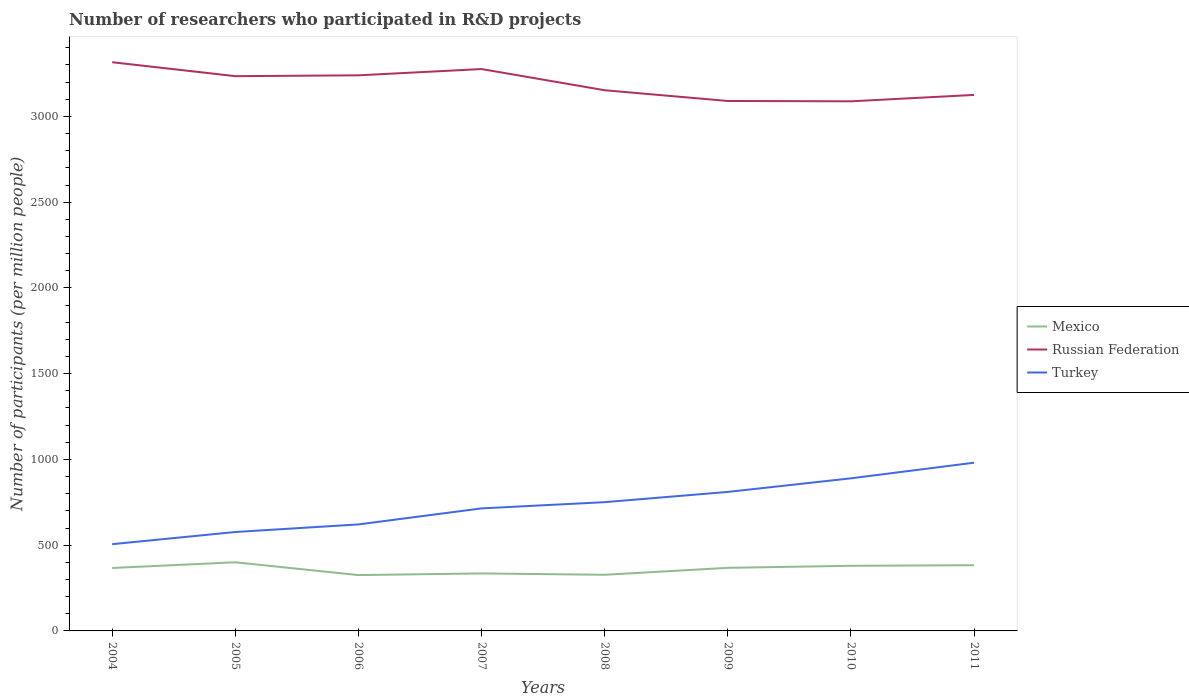Does the line corresponding to Turkey intersect with the line corresponding to Mexico?
Your answer should be very brief. No. Across all years, what is the maximum number of researchers who participated in R&D projects in Mexico?
Provide a short and direct response. 325.58. In which year was the number of researchers who participated in R&D projects in Russian Federation maximum?
Keep it short and to the point. 2010. What is the total number of researchers who participated in R&D projects in Mexico in the graph?
Ensure brevity in your answer.  -0.93. What is the difference between the highest and the second highest number of researchers who participated in R&D projects in Mexico?
Offer a terse response. 74.63. Is the number of researchers who participated in R&D projects in Mexico strictly greater than the number of researchers who participated in R&D projects in Russian Federation over the years?
Keep it short and to the point. Yes. How many lines are there?
Your response must be concise. 3. Are the values on the major ticks of Y-axis written in scientific E-notation?
Ensure brevity in your answer.  No. Does the graph contain any zero values?
Your response must be concise. No. Where does the legend appear in the graph?
Give a very brief answer. Center right. How many legend labels are there?
Provide a succinct answer. 3. What is the title of the graph?
Make the answer very short. Number of researchers who participated in R&D projects. What is the label or title of the Y-axis?
Provide a short and direct response. Number of participants (per million people). What is the Number of participants (per million people) in Mexico in 2004?
Provide a short and direct response. 366.94. What is the Number of participants (per million people) of Russian Federation in 2004?
Keep it short and to the point. 3315.98. What is the Number of participants (per million people) of Turkey in 2004?
Keep it short and to the point. 505.82. What is the Number of participants (per million people) in Mexico in 2005?
Offer a terse response. 400.21. What is the Number of participants (per million people) of Russian Federation in 2005?
Ensure brevity in your answer.  3234.71. What is the Number of participants (per million people) of Turkey in 2005?
Your response must be concise. 576.76. What is the Number of participants (per million people) in Mexico in 2006?
Your response must be concise. 325.58. What is the Number of participants (per million people) in Russian Federation in 2006?
Your answer should be compact. 3239.59. What is the Number of participants (per million people) in Turkey in 2006?
Your answer should be very brief. 620.97. What is the Number of participants (per million people) in Mexico in 2007?
Your response must be concise. 335.25. What is the Number of participants (per million people) of Russian Federation in 2007?
Your answer should be very brief. 3276.12. What is the Number of participants (per million people) in Turkey in 2007?
Provide a succinct answer. 714.49. What is the Number of participants (per million people) of Mexico in 2008?
Your answer should be compact. 327.37. What is the Number of participants (per million people) of Russian Federation in 2008?
Your response must be concise. 3152.62. What is the Number of participants (per million people) in Turkey in 2008?
Offer a terse response. 750.75. What is the Number of participants (per million people) of Mexico in 2009?
Your answer should be very brief. 367.87. What is the Number of participants (per million people) of Russian Federation in 2009?
Your answer should be compact. 3090.01. What is the Number of participants (per million people) in Turkey in 2009?
Offer a very short reply. 810.52. What is the Number of participants (per million people) of Mexico in 2010?
Offer a very short reply. 379.75. What is the Number of participants (per million people) of Russian Federation in 2010?
Your response must be concise. 3087.99. What is the Number of participants (per million people) in Turkey in 2010?
Provide a short and direct response. 889.79. What is the Number of participants (per million people) in Mexico in 2011?
Your answer should be very brief. 383.21. What is the Number of participants (per million people) of Russian Federation in 2011?
Your response must be concise. 3125.3. What is the Number of participants (per million people) in Turkey in 2011?
Keep it short and to the point. 980.84. Across all years, what is the maximum Number of participants (per million people) in Mexico?
Provide a short and direct response. 400.21. Across all years, what is the maximum Number of participants (per million people) in Russian Federation?
Offer a very short reply. 3315.98. Across all years, what is the maximum Number of participants (per million people) in Turkey?
Provide a succinct answer. 980.84. Across all years, what is the minimum Number of participants (per million people) in Mexico?
Keep it short and to the point. 325.58. Across all years, what is the minimum Number of participants (per million people) in Russian Federation?
Your answer should be compact. 3087.99. Across all years, what is the minimum Number of participants (per million people) of Turkey?
Provide a succinct answer. 505.82. What is the total Number of participants (per million people) in Mexico in the graph?
Keep it short and to the point. 2886.17. What is the total Number of participants (per million people) of Russian Federation in the graph?
Your answer should be compact. 2.55e+04. What is the total Number of participants (per million people) of Turkey in the graph?
Keep it short and to the point. 5849.93. What is the difference between the Number of participants (per million people) of Mexico in 2004 and that in 2005?
Ensure brevity in your answer.  -33.27. What is the difference between the Number of participants (per million people) of Russian Federation in 2004 and that in 2005?
Give a very brief answer. 81.27. What is the difference between the Number of participants (per million people) in Turkey in 2004 and that in 2005?
Keep it short and to the point. -70.94. What is the difference between the Number of participants (per million people) in Mexico in 2004 and that in 2006?
Provide a short and direct response. 41.36. What is the difference between the Number of participants (per million people) in Russian Federation in 2004 and that in 2006?
Provide a succinct answer. 76.4. What is the difference between the Number of participants (per million people) of Turkey in 2004 and that in 2006?
Provide a succinct answer. -115.15. What is the difference between the Number of participants (per million people) of Mexico in 2004 and that in 2007?
Give a very brief answer. 31.69. What is the difference between the Number of participants (per million people) of Russian Federation in 2004 and that in 2007?
Give a very brief answer. 39.86. What is the difference between the Number of participants (per million people) in Turkey in 2004 and that in 2007?
Your answer should be very brief. -208.67. What is the difference between the Number of participants (per million people) of Mexico in 2004 and that in 2008?
Ensure brevity in your answer.  39.57. What is the difference between the Number of participants (per million people) of Russian Federation in 2004 and that in 2008?
Provide a short and direct response. 163.36. What is the difference between the Number of participants (per million people) of Turkey in 2004 and that in 2008?
Provide a succinct answer. -244.93. What is the difference between the Number of participants (per million people) in Mexico in 2004 and that in 2009?
Provide a short and direct response. -0.93. What is the difference between the Number of participants (per million people) in Russian Federation in 2004 and that in 2009?
Offer a very short reply. 225.97. What is the difference between the Number of participants (per million people) of Turkey in 2004 and that in 2009?
Make the answer very short. -304.7. What is the difference between the Number of participants (per million people) of Mexico in 2004 and that in 2010?
Offer a terse response. -12.81. What is the difference between the Number of participants (per million people) in Russian Federation in 2004 and that in 2010?
Offer a terse response. 227.99. What is the difference between the Number of participants (per million people) in Turkey in 2004 and that in 2010?
Offer a very short reply. -383.97. What is the difference between the Number of participants (per million people) in Mexico in 2004 and that in 2011?
Keep it short and to the point. -16.27. What is the difference between the Number of participants (per million people) of Russian Federation in 2004 and that in 2011?
Your response must be concise. 190.68. What is the difference between the Number of participants (per million people) in Turkey in 2004 and that in 2011?
Offer a terse response. -475.02. What is the difference between the Number of participants (per million people) in Mexico in 2005 and that in 2006?
Your answer should be very brief. 74.63. What is the difference between the Number of participants (per million people) in Russian Federation in 2005 and that in 2006?
Ensure brevity in your answer.  -4.88. What is the difference between the Number of participants (per million people) of Turkey in 2005 and that in 2006?
Your answer should be very brief. -44.21. What is the difference between the Number of participants (per million people) in Mexico in 2005 and that in 2007?
Give a very brief answer. 64.96. What is the difference between the Number of participants (per million people) in Russian Federation in 2005 and that in 2007?
Provide a short and direct response. -41.41. What is the difference between the Number of participants (per million people) in Turkey in 2005 and that in 2007?
Your response must be concise. -137.73. What is the difference between the Number of participants (per million people) of Mexico in 2005 and that in 2008?
Your answer should be compact. 72.84. What is the difference between the Number of participants (per million people) in Russian Federation in 2005 and that in 2008?
Make the answer very short. 82.09. What is the difference between the Number of participants (per million people) in Turkey in 2005 and that in 2008?
Keep it short and to the point. -173.99. What is the difference between the Number of participants (per million people) in Mexico in 2005 and that in 2009?
Your answer should be compact. 32.34. What is the difference between the Number of participants (per million people) of Russian Federation in 2005 and that in 2009?
Offer a very short reply. 144.7. What is the difference between the Number of participants (per million people) of Turkey in 2005 and that in 2009?
Provide a succinct answer. -233.76. What is the difference between the Number of participants (per million people) of Mexico in 2005 and that in 2010?
Offer a very short reply. 20.46. What is the difference between the Number of participants (per million people) in Russian Federation in 2005 and that in 2010?
Ensure brevity in your answer.  146.72. What is the difference between the Number of participants (per million people) in Turkey in 2005 and that in 2010?
Offer a terse response. -313.03. What is the difference between the Number of participants (per million people) in Mexico in 2005 and that in 2011?
Offer a very short reply. 17. What is the difference between the Number of participants (per million people) of Russian Federation in 2005 and that in 2011?
Your answer should be compact. 109.41. What is the difference between the Number of participants (per million people) in Turkey in 2005 and that in 2011?
Give a very brief answer. -404.09. What is the difference between the Number of participants (per million people) of Mexico in 2006 and that in 2007?
Give a very brief answer. -9.67. What is the difference between the Number of participants (per million people) in Russian Federation in 2006 and that in 2007?
Offer a terse response. -36.54. What is the difference between the Number of participants (per million people) of Turkey in 2006 and that in 2007?
Offer a very short reply. -93.52. What is the difference between the Number of participants (per million people) in Mexico in 2006 and that in 2008?
Ensure brevity in your answer.  -1.79. What is the difference between the Number of participants (per million people) in Russian Federation in 2006 and that in 2008?
Offer a very short reply. 86.96. What is the difference between the Number of participants (per million people) of Turkey in 2006 and that in 2008?
Ensure brevity in your answer.  -129.78. What is the difference between the Number of participants (per million people) of Mexico in 2006 and that in 2009?
Ensure brevity in your answer.  -42.29. What is the difference between the Number of participants (per million people) of Russian Federation in 2006 and that in 2009?
Provide a short and direct response. 149.57. What is the difference between the Number of participants (per million people) of Turkey in 2006 and that in 2009?
Provide a short and direct response. -189.55. What is the difference between the Number of participants (per million people) of Mexico in 2006 and that in 2010?
Give a very brief answer. -54.17. What is the difference between the Number of participants (per million people) in Russian Federation in 2006 and that in 2010?
Provide a succinct answer. 151.59. What is the difference between the Number of participants (per million people) in Turkey in 2006 and that in 2010?
Your response must be concise. -268.82. What is the difference between the Number of participants (per million people) of Mexico in 2006 and that in 2011?
Offer a terse response. -57.63. What is the difference between the Number of participants (per million people) in Russian Federation in 2006 and that in 2011?
Make the answer very short. 114.28. What is the difference between the Number of participants (per million people) of Turkey in 2006 and that in 2011?
Give a very brief answer. -359.87. What is the difference between the Number of participants (per million people) in Mexico in 2007 and that in 2008?
Your answer should be compact. 7.88. What is the difference between the Number of participants (per million people) of Russian Federation in 2007 and that in 2008?
Provide a succinct answer. 123.5. What is the difference between the Number of participants (per million people) of Turkey in 2007 and that in 2008?
Your answer should be very brief. -36.26. What is the difference between the Number of participants (per million people) of Mexico in 2007 and that in 2009?
Give a very brief answer. -32.62. What is the difference between the Number of participants (per million people) of Russian Federation in 2007 and that in 2009?
Offer a very short reply. 186.11. What is the difference between the Number of participants (per million people) in Turkey in 2007 and that in 2009?
Offer a very short reply. -96.03. What is the difference between the Number of participants (per million people) of Mexico in 2007 and that in 2010?
Offer a very short reply. -44.5. What is the difference between the Number of participants (per million people) of Russian Federation in 2007 and that in 2010?
Give a very brief answer. 188.13. What is the difference between the Number of participants (per million people) of Turkey in 2007 and that in 2010?
Provide a short and direct response. -175.3. What is the difference between the Number of participants (per million people) of Mexico in 2007 and that in 2011?
Offer a terse response. -47.96. What is the difference between the Number of participants (per million people) of Russian Federation in 2007 and that in 2011?
Offer a very short reply. 150.82. What is the difference between the Number of participants (per million people) of Turkey in 2007 and that in 2011?
Provide a short and direct response. -266.36. What is the difference between the Number of participants (per million people) in Mexico in 2008 and that in 2009?
Keep it short and to the point. -40.49. What is the difference between the Number of participants (per million people) in Russian Federation in 2008 and that in 2009?
Give a very brief answer. 62.61. What is the difference between the Number of participants (per million people) in Turkey in 2008 and that in 2009?
Make the answer very short. -59.77. What is the difference between the Number of participants (per million people) of Mexico in 2008 and that in 2010?
Provide a short and direct response. -52.38. What is the difference between the Number of participants (per million people) of Russian Federation in 2008 and that in 2010?
Ensure brevity in your answer.  64.63. What is the difference between the Number of participants (per million people) in Turkey in 2008 and that in 2010?
Provide a short and direct response. -139.04. What is the difference between the Number of participants (per million people) in Mexico in 2008 and that in 2011?
Your response must be concise. -55.84. What is the difference between the Number of participants (per million people) of Russian Federation in 2008 and that in 2011?
Give a very brief answer. 27.32. What is the difference between the Number of participants (per million people) in Turkey in 2008 and that in 2011?
Offer a very short reply. -230.09. What is the difference between the Number of participants (per million people) of Mexico in 2009 and that in 2010?
Keep it short and to the point. -11.88. What is the difference between the Number of participants (per million people) of Russian Federation in 2009 and that in 2010?
Keep it short and to the point. 2.02. What is the difference between the Number of participants (per million people) of Turkey in 2009 and that in 2010?
Provide a short and direct response. -79.27. What is the difference between the Number of participants (per million people) in Mexico in 2009 and that in 2011?
Offer a terse response. -15.34. What is the difference between the Number of participants (per million people) in Russian Federation in 2009 and that in 2011?
Provide a short and direct response. -35.29. What is the difference between the Number of participants (per million people) of Turkey in 2009 and that in 2011?
Make the answer very short. -170.32. What is the difference between the Number of participants (per million people) of Mexico in 2010 and that in 2011?
Keep it short and to the point. -3.46. What is the difference between the Number of participants (per million people) in Russian Federation in 2010 and that in 2011?
Your answer should be compact. -37.31. What is the difference between the Number of participants (per million people) of Turkey in 2010 and that in 2011?
Ensure brevity in your answer.  -91.05. What is the difference between the Number of participants (per million people) of Mexico in 2004 and the Number of participants (per million people) of Russian Federation in 2005?
Your answer should be very brief. -2867.77. What is the difference between the Number of participants (per million people) in Mexico in 2004 and the Number of participants (per million people) in Turkey in 2005?
Your answer should be compact. -209.82. What is the difference between the Number of participants (per million people) of Russian Federation in 2004 and the Number of participants (per million people) of Turkey in 2005?
Ensure brevity in your answer.  2739.23. What is the difference between the Number of participants (per million people) in Mexico in 2004 and the Number of participants (per million people) in Russian Federation in 2006?
Your answer should be compact. -2872.65. What is the difference between the Number of participants (per million people) in Mexico in 2004 and the Number of participants (per million people) in Turkey in 2006?
Ensure brevity in your answer.  -254.03. What is the difference between the Number of participants (per million people) in Russian Federation in 2004 and the Number of participants (per million people) in Turkey in 2006?
Make the answer very short. 2695.01. What is the difference between the Number of participants (per million people) in Mexico in 2004 and the Number of participants (per million people) in Russian Federation in 2007?
Offer a very short reply. -2909.18. What is the difference between the Number of participants (per million people) of Mexico in 2004 and the Number of participants (per million people) of Turkey in 2007?
Keep it short and to the point. -347.55. What is the difference between the Number of participants (per million people) in Russian Federation in 2004 and the Number of participants (per million people) in Turkey in 2007?
Offer a very short reply. 2601.5. What is the difference between the Number of participants (per million people) of Mexico in 2004 and the Number of participants (per million people) of Russian Federation in 2008?
Offer a terse response. -2785.68. What is the difference between the Number of participants (per million people) in Mexico in 2004 and the Number of participants (per million people) in Turkey in 2008?
Provide a short and direct response. -383.81. What is the difference between the Number of participants (per million people) in Russian Federation in 2004 and the Number of participants (per million people) in Turkey in 2008?
Keep it short and to the point. 2565.23. What is the difference between the Number of participants (per million people) of Mexico in 2004 and the Number of participants (per million people) of Russian Federation in 2009?
Give a very brief answer. -2723.07. What is the difference between the Number of participants (per million people) in Mexico in 2004 and the Number of participants (per million people) in Turkey in 2009?
Ensure brevity in your answer.  -443.58. What is the difference between the Number of participants (per million people) of Russian Federation in 2004 and the Number of participants (per million people) of Turkey in 2009?
Ensure brevity in your answer.  2505.46. What is the difference between the Number of participants (per million people) in Mexico in 2004 and the Number of participants (per million people) in Russian Federation in 2010?
Your response must be concise. -2721.05. What is the difference between the Number of participants (per million people) of Mexico in 2004 and the Number of participants (per million people) of Turkey in 2010?
Ensure brevity in your answer.  -522.85. What is the difference between the Number of participants (per million people) in Russian Federation in 2004 and the Number of participants (per million people) in Turkey in 2010?
Your response must be concise. 2426.19. What is the difference between the Number of participants (per million people) of Mexico in 2004 and the Number of participants (per million people) of Russian Federation in 2011?
Offer a terse response. -2758.36. What is the difference between the Number of participants (per million people) of Mexico in 2004 and the Number of participants (per million people) of Turkey in 2011?
Give a very brief answer. -613.9. What is the difference between the Number of participants (per million people) of Russian Federation in 2004 and the Number of participants (per million people) of Turkey in 2011?
Your response must be concise. 2335.14. What is the difference between the Number of participants (per million people) of Mexico in 2005 and the Number of participants (per million people) of Russian Federation in 2006?
Offer a terse response. -2839.38. What is the difference between the Number of participants (per million people) of Mexico in 2005 and the Number of participants (per million people) of Turkey in 2006?
Provide a short and direct response. -220.76. What is the difference between the Number of participants (per million people) of Russian Federation in 2005 and the Number of participants (per million people) of Turkey in 2006?
Provide a succinct answer. 2613.74. What is the difference between the Number of participants (per million people) of Mexico in 2005 and the Number of participants (per million people) of Russian Federation in 2007?
Offer a terse response. -2875.91. What is the difference between the Number of participants (per million people) of Mexico in 2005 and the Number of participants (per million people) of Turkey in 2007?
Provide a short and direct response. -314.28. What is the difference between the Number of participants (per million people) of Russian Federation in 2005 and the Number of participants (per million people) of Turkey in 2007?
Make the answer very short. 2520.22. What is the difference between the Number of participants (per million people) in Mexico in 2005 and the Number of participants (per million people) in Russian Federation in 2008?
Your answer should be very brief. -2752.41. What is the difference between the Number of participants (per million people) of Mexico in 2005 and the Number of participants (per million people) of Turkey in 2008?
Your answer should be very brief. -350.54. What is the difference between the Number of participants (per million people) of Russian Federation in 2005 and the Number of participants (per million people) of Turkey in 2008?
Give a very brief answer. 2483.96. What is the difference between the Number of participants (per million people) in Mexico in 2005 and the Number of participants (per million people) in Russian Federation in 2009?
Provide a succinct answer. -2689.8. What is the difference between the Number of participants (per million people) of Mexico in 2005 and the Number of participants (per million people) of Turkey in 2009?
Offer a very short reply. -410.31. What is the difference between the Number of participants (per million people) in Russian Federation in 2005 and the Number of participants (per million people) in Turkey in 2009?
Ensure brevity in your answer.  2424.19. What is the difference between the Number of participants (per million people) in Mexico in 2005 and the Number of participants (per million people) in Russian Federation in 2010?
Offer a terse response. -2687.78. What is the difference between the Number of participants (per million people) of Mexico in 2005 and the Number of participants (per million people) of Turkey in 2010?
Offer a terse response. -489.58. What is the difference between the Number of participants (per million people) of Russian Federation in 2005 and the Number of participants (per million people) of Turkey in 2010?
Offer a terse response. 2344.92. What is the difference between the Number of participants (per million people) in Mexico in 2005 and the Number of participants (per million people) in Russian Federation in 2011?
Offer a terse response. -2725.09. What is the difference between the Number of participants (per million people) in Mexico in 2005 and the Number of participants (per million people) in Turkey in 2011?
Provide a short and direct response. -580.63. What is the difference between the Number of participants (per million people) in Russian Federation in 2005 and the Number of participants (per million people) in Turkey in 2011?
Keep it short and to the point. 2253.87. What is the difference between the Number of participants (per million people) in Mexico in 2006 and the Number of participants (per million people) in Russian Federation in 2007?
Provide a short and direct response. -2950.54. What is the difference between the Number of participants (per million people) of Mexico in 2006 and the Number of participants (per million people) of Turkey in 2007?
Provide a succinct answer. -388.91. What is the difference between the Number of participants (per million people) in Russian Federation in 2006 and the Number of participants (per million people) in Turkey in 2007?
Your answer should be compact. 2525.1. What is the difference between the Number of participants (per million people) of Mexico in 2006 and the Number of participants (per million people) of Russian Federation in 2008?
Ensure brevity in your answer.  -2827.04. What is the difference between the Number of participants (per million people) of Mexico in 2006 and the Number of participants (per million people) of Turkey in 2008?
Your answer should be compact. -425.17. What is the difference between the Number of participants (per million people) of Russian Federation in 2006 and the Number of participants (per million people) of Turkey in 2008?
Provide a succinct answer. 2488.84. What is the difference between the Number of participants (per million people) in Mexico in 2006 and the Number of participants (per million people) in Russian Federation in 2009?
Your response must be concise. -2764.43. What is the difference between the Number of participants (per million people) of Mexico in 2006 and the Number of participants (per million people) of Turkey in 2009?
Provide a short and direct response. -484.94. What is the difference between the Number of participants (per million people) of Russian Federation in 2006 and the Number of participants (per million people) of Turkey in 2009?
Give a very brief answer. 2429.07. What is the difference between the Number of participants (per million people) in Mexico in 2006 and the Number of participants (per million people) in Russian Federation in 2010?
Your answer should be very brief. -2762.41. What is the difference between the Number of participants (per million people) in Mexico in 2006 and the Number of participants (per million people) in Turkey in 2010?
Ensure brevity in your answer.  -564.21. What is the difference between the Number of participants (per million people) in Russian Federation in 2006 and the Number of participants (per million people) in Turkey in 2010?
Make the answer very short. 2349.8. What is the difference between the Number of participants (per million people) in Mexico in 2006 and the Number of participants (per million people) in Russian Federation in 2011?
Ensure brevity in your answer.  -2799.72. What is the difference between the Number of participants (per million people) in Mexico in 2006 and the Number of participants (per million people) in Turkey in 2011?
Offer a very short reply. -655.26. What is the difference between the Number of participants (per million people) in Russian Federation in 2006 and the Number of participants (per million people) in Turkey in 2011?
Offer a very short reply. 2258.74. What is the difference between the Number of participants (per million people) of Mexico in 2007 and the Number of participants (per million people) of Russian Federation in 2008?
Provide a succinct answer. -2817.37. What is the difference between the Number of participants (per million people) in Mexico in 2007 and the Number of participants (per million people) in Turkey in 2008?
Ensure brevity in your answer.  -415.5. What is the difference between the Number of participants (per million people) in Russian Federation in 2007 and the Number of participants (per million people) in Turkey in 2008?
Offer a very short reply. 2525.37. What is the difference between the Number of participants (per million people) in Mexico in 2007 and the Number of participants (per million people) in Russian Federation in 2009?
Make the answer very short. -2754.76. What is the difference between the Number of participants (per million people) in Mexico in 2007 and the Number of participants (per million people) in Turkey in 2009?
Your response must be concise. -475.27. What is the difference between the Number of participants (per million people) in Russian Federation in 2007 and the Number of participants (per million people) in Turkey in 2009?
Keep it short and to the point. 2465.6. What is the difference between the Number of participants (per million people) in Mexico in 2007 and the Number of participants (per million people) in Russian Federation in 2010?
Your answer should be compact. -2752.74. What is the difference between the Number of participants (per million people) in Mexico in 2007 and the Number of participants (per million people) in Turkey in 2010?
Give a very brief answer. -554.54. What is the difference between the Number of participants (per million people) of Russian Federation in 2007 and the Number of participants (per million people) of Turkey in 2010?
Provide a short and direct response. 2386.33. What is the difference between the Number of participants (per million people) of Mexico in 2007 and the Number of participants (per million people) of Russian Federation in 2011?
Offer a terse response. -2790.05. What is the difference between the Number of participants (per million people) of Mexico in 2007 and the Number of participants (per million people) of Turkey in 2011?
Make the answer very short. -645.59. What is the difference between the Number of participants (per million people) in Russian Federation in 2007 and the Number of participants (per million people) in Turkey in 2011?
Provide a short and direct response. 2295.28. What is the difference between the Number of participants (per million people) of Mexico in 2008 and the Number of participants (per million people) of Russian Federation in 2009?
Your answer should be very brief. -2762.64. What is the difference between the Number of participants (per million people) in Mexico in 2008 and the Number of participants (per million people) in Turkey in 2009?
Keep it short and to the point. -483.15. What is the difference between the Number of participants (per million people) in Russian Federation in 2008 and the Number of participants (per million people) in Turkey in 2009?
Keep it short and to the point. 2342.1. What is the difference between the Number of participants (per million people) in Mexico in 2008 and the Number of participants (per million people) in Russian Federation in 2010?
Offer a very short reply. -2760.62. What is the difference between the Number of participants (per million people) of Mexico in 2008 and the Number of participants (per million people) of Turkey in 2010?
Ensure brevity in your answer.  -562.42. What is the difference between the Number of participants (per million people) in Russian Federation in 2008 and the Number of participants (per million people) in Turkey in 2010?
Ensure brevity in your answer.  2262.83. What is the difference between the Number of participants (per million people) of Mexico in 2008 and the Number of participants (per million people) of Russian Federation in 2011?
Ensure brevity in your answer.  -2797.93. What is the difference between the Number of participants (per million people) in Mexico in 2008 and the Number of participants (per million people) in Turkey in 2011?
Make the answer very short. -653.47. What is the difference between the Number of participants (per million people) in Russian Federation in 2008 and the Number of participants (per million people) in Turkey in 2011?
Ensure brevity in your answer.  2171.78. What is the difference between the Number of participants (per million people) of Mexico in 2009 and the Number of participants (per million people) of Russian Federation in 2010?
Provide a short and direct response. -2720.12. What is the difference between the Number of participants (per million people) in Mexico in 2009 and the Number of participants (per million people) in Turkey in 2010?
Offer a terse response. -521.92. What is the difference between the Number of participants (per million people) of Russian Federation in 2009 and the Number of participants (per million people) of Turkey in 2010?
Provide a succinct answer. 2200.22. What is the difference between the Number of participants (per million people) in Mexico in 2009 and the Number of participants (per million people) in Russian Federation in 2011?
Offer a terse response. -2757.43. What is the difference between the Number of participants (per million people) of Mexico in 2009 and the Number of participants (per million people) of Turkey in 2011?
Your answer should be very brief. -612.98. What is the difference between the Number of participants (per million people) in Russian Federation in 2009 and the Number of participants (per million people) in Turkey in 2011?
Your response must be concise. 2109.17. What is the difference between the Number of participants (per million people) in Mexico in 2010 and the Number of participants (per million people) in Russian Federation in 2011?
Your response must be concise. -2745.55. What is the difference between the Number of participants (per million people) of Mexico in 2010 and the Number of participants (per million people) of Turkey in 2011?
Make the answer very short. -601.09. What is the difference between the Number of participants (per million people) in Russian Federation in 2010 and the Number of participants (per million people) in Turkey in 2011?
Offer a very short reply. 2107.15. What is the average Number of participants (per million people) of Mexico per year?
Your answer should be very brief. 360.77. What is the average Number of participants (per million people) of Russian Federation per year?
Keep it short and to the point. 3190.29. What is the average Number of participants (per million people) in Turkey per year?
Offer a terse response. 731.24. In the year 2004, what is the difference between the Number of participants (per million people) of Mexico and Number of participants (per million people) of Russian Federation?
Your answer should be compact. -2949.04. In the year 2004, what is the difference between the Number of participants (per million people) of Mexico and Number of participants (per million people) of Turkey?
Your answer should be compact. -138.88. In the year 2004, what is the difference between the Number of participants (per million people) in Russian Federation and Number of participants (per million people) in Turkey?
Offer a very short reply. 2810.16. In the year 2005, what is the difference between the Number of participants (per million people) in Mexico and Number of participants (per million people) in Russian Federation?
Offer a very short reply. -2834.5. In the year 2005, what is the difference between the Number of participants (per million people) in Mexico and Number of participants (per million people) in Turkey?
Make the answer very short. -176.55. In the year 2005, what is the difference between the Number of participants (per million people) in Russian Federation and Number of participants (per million people) in Turkey?
Your answer should be compact. 2657.95. In the year 2006, what is the difference between the Number of participants (per million people) in Mexico and Number of participants (per million people) in Russian Federation?
Your answer should be very brief. -2914.01. In the year 2006, what is the difference between the Number of participants (per million people) in Mexico and Number of participants (per million people) in Turkey?
Keep it short and to the point. -295.39. In the year 2006, what is the difference between the Number of participants (per million people) of Russian Federation and Number of participants (per million people) of Turkey?
Your answer should be compact. 2618.62. In the year 2007, what is the difference between the Number of participants (per million people) of Mexico and Number of participants (per million people) of Russian Federation?
Provide a succinct answer. -2940.87. In the year 2007, what is the difference between the Number of participants (per million people) of Mexico and Number of participants (per million people) of Turkey?
Offer a terse response. -379.24. In the year 2007, what is the difference between the Number of participants (per million people) of Russian Federation and Number of participants (per million people) of Turkey?
Ensure brevity in your answer.  2561.64. In the year 2008, what is the difference between the Number of participants (per million people) in Mexico and Number of participants (per million people) in Russian Federation?
Ensure brevity in your answer.  -2825.25. In the year 2008, what is the difference between the Number of participants (per million people) in Mexico and Number of participants (per million people) in Turkey?
Offer a very short reply. -423.38. In the year 2008, what is the difference between the Number of participants (per million people) in Russian Federation and Number of participants (per million people) in Turkey?
Ensure brevity in your answer.  2401.87. In the year 2009, what is the difference between the Number of participants (per million people) in Mexico and Number of participants (per million people) in Russian Federation?
Make the answer very short. -2722.14. In the year 2009, what is the difference between the Number of participants (per million people) of Mexico and Number of participants (per million people) of Turkey?
Offer a very short reply. -442.65. In the year 2009, what is the difference between the Number of participants (per million people) in Russian Federation and Number of participants (per million people) in Turkey?
Offer a very short reply. 2279.49. In the year 2010, what is the difference between the Number of participants (per million people) of Mexico and Number of participants (per million people) of Russian Federation?
Provide a short and direct response. -2708.24. In the year 2010, what is the difference between the Number of participants (per million people) in Mexico and Number of participants (per million people) in Turkey?
Make the answer very short. -510.04. In the year 2010, what is the difference between the Number of participants (per million people) in Russian Federation and Number of participants (per million people) in Turkey?
Ensure brevity in your answer.  2198.2. In the year 2011, what is the difference between the Number of participants (per million people) of Mexico and Number of participants (per million people) of Russian Federation?
Your answer should be very brief. -2742.09. In the year 2011, what is the difference between the Number of participants (per million people) of Mexico and Number of participants (per million people) of Turkey?
Your response must be concise. -597.63. In the year 2011, what is the difference between the Number of participants (per million people) of Russian Federation and Number of participants (per million people) of Turkey?
Give a very brief answer. 2144.46. What is the ratio of the Number of participants (per million people) in Mexico in 2004 to that in 2005?
Provide a succinct answer. 0.92. What is the ratio of the Number of participants (per million people) of Russian Federation in 2004 to that in 2005?
Offer a very short reply. 1.03. What is the ratio of the Number of participants (per million people) in Turkey in 2004 to that in 2005?
Provide a short and direct response. 0.88. What is the ratio of the Number of participants (per million people) in Mexico in 2004 to that in 2006?
Offer a very short reply. 1.13. What is the ratio of the Number of participants (per million people) of Russian Federation in 2004 to that in 2006?
Your answer should be very brief. 1.02. What is the ratio of the Number of participants (per million people) in Turkey in 2004 to that in 2006?
Your response must be concise. 0.81. What is the ratio of the Number of participants (per million people) of Mexico in 2004 to that in 2007?
Your answer should be compact. 1.09. What is the ratio of the Number of participants (per million people) of Russian Federation in 2004 to that in 2007?
Offer a terse response. 1.01. What is the ratio of the Number of participants (per million people) of Turkey in 2004 to that in 2007?
Your answer should be very brief. 0.71. What is the ratio of the Number of participants (per million people) of Mexico in 2004 to that in 2008?
Provide a succinct answer. 1.12. What is the ratio of the Number of participants (per million people) in Russian Federation in 2004 to that in 2008?
Offer a very short reply. 1.05. What is the ratio of the Number of participants (per million people) of Turkey in 2004 to that in 2008?
Keep it short and to the point. 0.67. What is the ratio of the Number of participants (per million people) in Mexico in 2004 to that in 2009?
Your response must be concise. 1. What is the ratio of the Number of participants (per million people) of Russian Federation in 2004 to that in 2009?
Make the answer very short. 1.07. What is the ratio of the Number of participants (per million people) in Turkey in 2004 to that in 2009?
Ensure brevity in your answer.  0.62. What is the ratio of the Number of participants (per million people) of Mexico in 2004 to that in 2010?
Offer a very short reply. 0.97. What is the ratio of the Number of participants (per million people) of Russian Federation in 2004 to that in 2010?
Make the answer very short. 1.07. What is the ratio of the Number of participants (per million people) of Turkey in 2004 to that in 2010?
Your answer should be very brief. 0.57. What is the ratio of the Number of participants (per million people) in Mexico in 2004 to that in 2011?
Offer a very short reply. 0.96. What is the ratio of the Number of participants (per million people) in Russian Federation in 2004 to that in 2011?
Your response must be concise. 1.06. What is the ratio of the Number of participants (per million people) of Turkey in 2004 to that in 2011?
Your answer should be very brief. 0.52. What is the ratio of the Number of participants (per million people) in Mexico in 2005 to that in 2006?
Make the answer very short. 1.23. What is the ratio of the Number of participants (per million people) of Russian Federation in 2005 to that in 2006?
Your answer should be very brief. 1. What is the ratio of the Number of participants (per million people) in Turkey in 2005 to that in 2006?
Keep it short and to the point. 0.93. What is the ratio of the Number of participants (per million people) in Mexico in 2005 to that in 2007?
Ensure brevity in your answer.  1.19. What is the ratio of the Number of participants (per million people) of Russian Federation in 2005 to that in 2007?
Offer a very short reply. 0.99. What is the ratio of the Number of participants (per million people) in Turkey in 2005 to that in 2007?
Make the answer very short. 0.81. What is the ratio of the Number of participants (per million people) of Mexico in 2005 to that in 2008?
Offer a very short reply. 1.22. What is the ratio of the Number of participants (per million people) of Turkey in 2005 to that in 2008?
Your answer should be very brief. 0.77. What is the ratio of the Number of participants (per million people) of Mexico in 2005 to that in 2009?
Your answer should be compact. 1.09. What is the ratio of the Number of participants (per million people) of Russian Federation in 2005 to that in 2009?
Provide a succinct answer. 1.05. What is the ratio of the Number of participants (per million people) of Turkey in 2005 to that in 2009?
Your answer should be compact. 0.71. What is the ratio of the Number of participants (per million people) in Mexico in 2005 to that in 2010?
Ensure brevity in your answer.  1.05. What is the ratio of the Number of participants (per million people) of Russian Federation in 2005 to that in 2010?
Your answer should be compact. 1.05. What is the ratio of the Number of participants (per million people) of Turkey in 2005 to that in 2010?
Your response must be concise. 0.65. What is the ratio of the Number of participants (per million people) of Mexico in 2005 to that in 2011?
Your answer should be compact. 1.04. What is the ratio of the Number of participants (per million people) of Russian Federation in 2005 to that in 2011?
Make the answer very short. 1.03. What is the ratio of the Number of participants (per million people) in Turkey in 2005 to that in 2011?
Your response must be concise. 0.59. What is the ratio of the Number of participants (per million people) in Mexico in 2006 to that in 2007?
Keep it short and to the point. 0.97. What is the ratio of the Number of participants (per million people) in Russian Federation in 2006 to that in 2007?
Keep it short and to the point. 0.99. What is the ratio of the Number of participants (per million people) of Turkey in 2006 to that in 2007?
Provide a short and direct response. 0.87. What is the ratio of the Number of participants (per million people) in Russian Federation in 2006 to that in 2008?
Offer a terse response. 1.03. What is the ratio of the Number of participants (per million people) of Turkey in 2006 to that in 2008?
Ensure brevity in your answer.  0.83. What is the ratio of the Number of participants (per million people) in Mexico in 2006 to that in 2009?
Offer a terse response. 0.89. What is the ratio of the Number of participants (per million people) in Russian Federation in 2006 to that in 2009?
Your answer should be very brief. 1.05. What is the ratio of the Number of participants (per million people) in Turkey in 2006 to that in 2009?
Provide a succinct answer. 0.77. What is the ratio of the Number of participants (per million people) in Mexico in 2006 to that in 2010?
Give a very brief answer. 0.86. What is the ratio of the Number of participants (per million people) of Russian Federation in 2006 to that in 2010?
Ensure brevity in your answer.  1.05. What is the ratio of the Number of participants (per million people) in Turkey in 2006 to that in 2010?
Offer a terse response. 0.7. What is the ratio of the Number of participants (per million people) in Mexico in 2006 to that in 2011?
Ensure brevity in your answer.  0.85. What is the ratio of the Number of participants (per million people) of Russian Federation in 2006 to that in 2011?
Offer a terse response. 1.04. What is the ratio of the Number of participants (per million people) in Turkey in 2006 to that in 2011?
Your response must be concise. 0.63. What is the ratio of the Number of participants (per million people) in Mexico in 2007 to that in 2008?
Give a very brief answer. 1.02. What is the ratio of the Number of participants (per million people) of Russian Federation in 2007 to that in 2008?
Make the answer very short. 1.04. What is the ratio of the Number of participants (per million people) in Turkey in 2007 to that in 2008?
Offer a terse response. 0.95. What is the ratio of the Number of participants (per million people) of Mexico in 2007 to that in 2009?
Offer a very short reply. 0.91. What is the ratio of the Number of participants (per million people) in Russian Federation in 2007 to that in 2009?
Give a very brief answer. 1.06. What is the ratio of the Number of participants (per million people) in Turkey in 2007 to that in 2009?
Your response must be concise. 0.88. What is the ratio of the Number of participants (per million people) of Mexico in 2007 to that in 2010?
Your answer should be very brief. 0.88. What is the ratio of the Number of participants (per million people) of Russian Federation in 2007 to that in 2010?
Make the answer very short. 1.06. What is the ratio of the Number of participants (per million people) in Turkey in 2007 to that in 2010?
Provide a succinct answer. 0.8. What is the ratio of the Number of participants (per million people) in Mexico in 2007 to that in 2011?
Offer a terse response. 0.87. What is the ratio of the Number of participants (per million people) of Russian Federation in 2007 to that in 2011?
Your response must be concise. 1.05. What is the ratio of the Number of participants (per million people) of Turkey in 2007 to that in 2011?
Your response must be concise. 0.73. What is the ratio of the Number of participants (per million people) in Mexico in 2008 to that in 2009?
Provide a short and direct response. 0.89. What is the ratio of the Number of participants (per million people) of Russian Federation in 2008 to that in 2009?
Provide a succinct answer. 1.02. What is the ratio of the Number of participants (per million people) in Turkey in 2008 to that in 2009?
Keep it short and to the point. 0.93. What is the ratio of the Number of participants (per million people) of Mexico in 2008 to that in 2010?
Provide a short and direct response. 0.86. What is the ratio of the Number of participants (per million people) in Russian Federation in 2008 to that in 2010?
Keep it short and to the point. 1.02. What is the ratio of the Number of participants (per million people) of Turkey in 2008 to that in 2010?
Make the answer very short. 0.84. What is the ratio of the Number of participants (per million people) of Mexico in 2008 to that in 2011?
Offer a very short reply. 0.85. What is the ratio of the Number of participants (per million people) of Russian Federation in 2008 to that in 2011?
Make the answer very short. 1.01. What is the ratio of the Number of participants (per million people) in Turkey in 2008 to that in 2011?
Provide a succinct answer. 0.77. What is the ratio of the Number of participants (per million people) in Mexico in 2009 to that in 2010?
Your answer should be compact. 0.97. What is the ratio of the Number of participants (per million people) in Russian Federation in 2009 to that in 2010?
Offer a very short reply. 1. What is the ratio of the Number of participants (per million people) in Turkey in 2009 to that in 2010?
Offer a very short reply. 0.91. What is the ratio of the Number of participants (per million people) of Mexico in 2009 to that in 2011?
Keep it short and to the point. 0.96. What is the ratio of the Number of participants (per million people) of Russian Federation in 2009 to that in 2011?
Make the answer very short. 0.99. What is the ratio of the Number of participants (per million people) in Turkey in 2009 to that in 2011?
Make the answer very short. 0.83. What is the ratio of the Number of participants (per million people) of Turkey in 2010 to that in 2011?
Offer a very short reply. 0.91. What is the difference between the highest and the second highest Number of participants (per million people) of Mexico?
Give a very brief answer. 17. What is the difference between the highest and the second highest Number of participants (per million people) of Russian Federation?
Provide a succinct answer. 39.86. What is the difference between the highest and the second highest Number of participants (per million people) in Turkey?
Keep it short and to the point. 91.05. What is the difference between the highest and the lowest Number of participants (per million people) in Mexico?
Ensure brevity in your answer.  74.63. What is the difference between the highest and the lowest Number of participants (per million people) in Russian Federation?
Offer a very short reply. 227.99. What is the difference between the highest and the lowest Number of participants (per million people) in Turkey?
Ensure brevity in your answer.  475.02. 